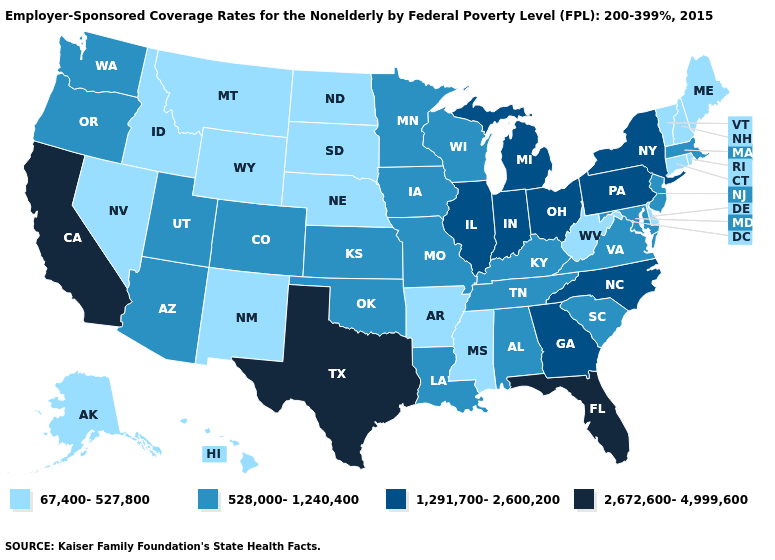Does Maryland have the highest value in the USA?
Quick response, please. No. Which states have the highest value in the USA?
Keep it brief. California, Florida, Texas. What is the lowest value in the South?
Short answer required. 67,400-527,800. Which states have the highest value in the USA?
Write a very short answer. California, Florida, Texas. What is the highest value in the West ?
Be succinct. 2,672,600-4,999,600. Among the states that border Utah , does New Mexico have the lowest value?
Short answer required. Yes. What is the highest value in the USA?
Short answer required. 2,672,600-4,999,600. Does Nebraska have the same value as Nevada?
Be succinct. Yes. What is the lowest value in the USA?
Be succinct. 67,400-527,800. Does North Dakota have the highest value in the MidWest?
Quick response, please. No. Which states have the lowest value in the MidWest?
Short answer required. Nebraska, North Dakota, South Dakota. What is the lowest value in the West?
Quick response, please. 67,400-527,800. Among the states that border Indiana , which have the highest value?
Write a very short answer. Illinois, Michigan, Ohio. What is the lowest value in states that border South Dakota?
Give a very brief answer. 67,400-527,800. Is the legend a continuous bar?
Keep it brief. No. 